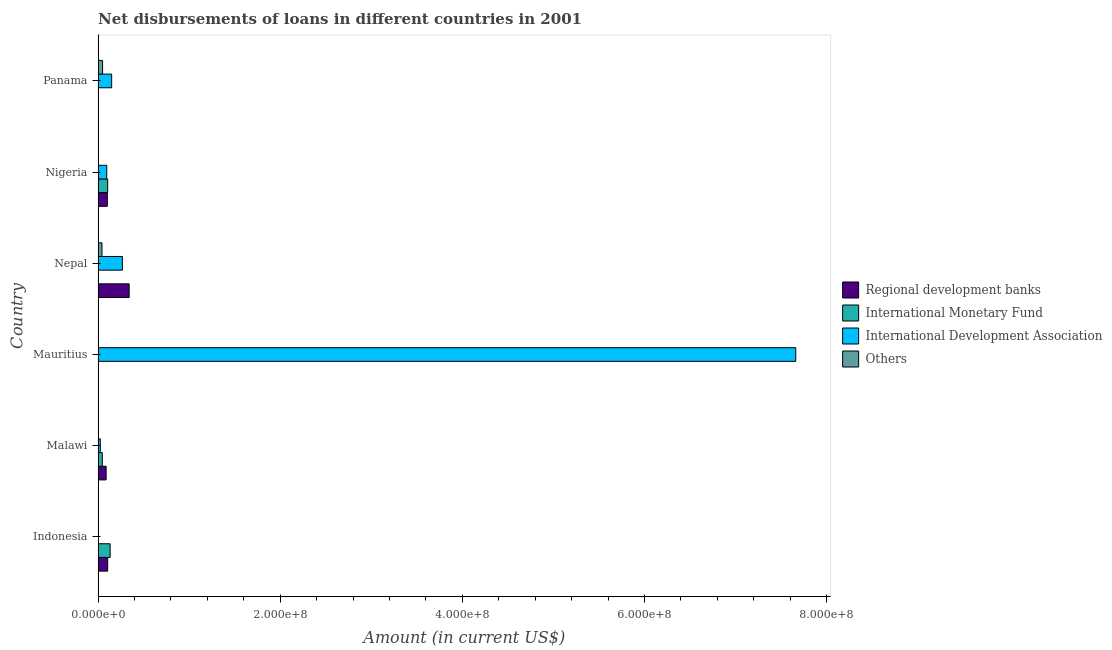Are the number of bars per tick equal to the number of legend labels?
Your answer should be compact. No. How many bars are there on the 3rd tick from the top?
Your response must be concise. 3. How many bars are there on the 4th tick from the bottom?
Offer a very short reply. 3. What is the label of the 3rd group of bars from the top?
Your answer should be compact. Nepal. What is the amount of loan disimbursed by other organisations in Indonesia?
Provide a short and direct response. 0. Across all countries, what is the maximum amount of loan disimbursed by international development association?
Give a very brief answer. 7.66e+08. Across all countries, what is the minimum amount of loan disimbursed by other organisations?
Make the answer very short. 0. In which country was the amount of loan disimbursed by international development association maximum?
Offer a very short reply. Mauritius. What is the total amount of loan disimbursed by international development association in the graph?
Your response must be concise. 8.19e+08. What is the difference between the amount of loan disimbursed by international monetary fund in Nigeria and the amount of loan disimbursed by international development association in Malawi?
Offer a terse response. 8.12e+06. What is the average amount of loan disimbursed by international development association per country?
Provide a succinct answer. 1.37e+08. What is the difference between the amount of loan disimbursed by international development association and amount of loan disimbursed by other organisations in Panama?
Offer a very short reply. 9.98e+06. What is the ratio of the amount of loan disimbursed by international development association in Mauritius to that in Nigeria?
Your response must be concise. 80.65. Is the amount of loan disimbursed by regional development banks in Indonesia less than that in Malawi?
Offer a terse response. No. What is the difference between the highest and the second highest amount of loan disimbursed by international monetary fund?
Provide a short and direct response. 2.71e+06. What is the difference between the highest and the lowest amount of loan disimbursed by regional development banks?
Offer a very short reply. 3.41e+07. In how many countries, is the amount of loan disimbursed by regional development banks greater than the average amount of loan disimbursed by regional development banks taken over all countries?
Provide a succinct answer. 1. Is the sum of the amount of loan disimbursed by international monetary fund in Indonesia and Malawi greater than the maximum amount of loan disimbursed by regional development banks across all countries?
Your answer should be very brief. No. Is it the case that in every country, the sum of the amount of loan disimbursed by regional development banks and amount of loan disimbursed by international monetary fund is greater than the amount of loan disimbursed by international development association?
Make the answer very short. No. How many bars are there?
Keep it short and to the point. 14. How many countries are there in the graph?
Ensure brevity in your answer.  6. Where does the legend appear in the graph?
Provide a short and direct response. Center right. How many legend labels are there?
Give a very brief answer. 4. What is the title of the graph?
Offer a very short reply. Net disbursements of loans in different countries in 2001. Does "Coal" appear as one of the legend labels in the graph?
Offer a very short reply. No. What is the label or title of the Y-axis?
Give a very brief answer. Country. What is the Amount (in current US$) of Regional development banks in Indonesia?
Keep it short and to the point. 1.05e+07. What is the Amount (in current US$) of International Monetary Fund in Indonesia?
Your answer should be compact. 1.32e+07. What is the Amount (in current US$) of Regional development banks in Malawi?
Make the answer very short. 8.80e+06. What is the Amount (in current US$) in International Monetary Fund in Malawi?
Ensure brevity in your answer.  4.59e+06. What is the Amount (in current US$) in International Development Association in Malawi?
Provide a succinct answer. 2.37e+06. What is the Amount (in current US$) in Others in Malawi?
Your answer should be very brief. 0. What is the Amount (in current US$) of Regional development banks in Mauritius?
Make the answer very short. 0. What is the Amount (in current US$) of International Monetary Fund in Mauritius?
Keep it short and to the point. 0. What is the Amount (in current US$) in International Development Association in Mauritius?
Your response must be concise. 7.66e+08. What is the Amount (in current US$) in Others in Mauritius?
Provide a short and direct response. 0. What is the Amount (in current US$) in Regional development banks in Nepal?
Your answer should be very brief. 3.41e+07. What is the Amount (in current US$) in International Development Association in Nepal?
Your response must be concise. 2.67e+07. What is the Amount (in current US$) of Others in Nepal?
Your response must be concise. 4.25e+06. What is the Amount (in current US$) in Regional development banks in Nigeria?
Ensure brevity in your answer.  1.01e+07. What is the Amount (in current US$) of International Monetary Fund in Nigeria?
Give a very brief answer. 1.05e+07. What is the Amount (in current US$) of International Development Association in Nigeria?
Keep it short and to the point. 9.50e+06. What is the Amount (in current US$) in Others in Nigeria?
Make the answer very short. 0. What is the Amount (in current US$) of International Monetary Fund in Panama?
Offer a very short reply. 0. What is the Amount (in current US$) in International Development Association in Panama?
Offer a very short reply. 1.49e+07. What is the Amount (in current US$) in Others in Panama?
Offer a very short reply. 4.90e+06. Across all countries, what is the maximum Amount (in current US$) of Regional development banks?
Provide a short and direct response. 3.41e+07. Across all countries, what is the maximum Amount (in current US$) of International Monetary Fund?
Offer a very short reply. 1.32e+07. Across all countries, what is the maximum Amount (in current US$) of International Development Association?
Provide a succinct answer. 7.66e+08. Across all countries, what is the maximum Amount (in current US$) in Others?
Your answer should be very brief. 4.90e+06. Across all countries, what is the minimum Amount (in current US$) of International Development Association?
Give a very brief answer. 0. Across all countries, what is the minimum Amount (in current US$) in Others?
Your answer should be compact. 0. What is the total Amount (in current US$) in Regional development banks in the graph?
Offer a very short reply. 6.35e+07. What is the total Amount (in current US$) in International Monetary Fund in the graph?
Your answer should be compact. 2.83e+07. What is the total Amount (in current US$) in International Development Association in the graph?
Your answer should be very brief. 8.19e+08. What is the total Amount (in current US$) in Others in the graph?
Make the answer very short. 9.15e+06. What is the difference between the Amount (in current US$) in Regional development banks in Indonesia and that in Malawi?
Your answer should be very brief. 1.70e+06. What is the difference between the Amount (in current US$) of International Monetary Fund in Indonesia and that in Malawi?
Give a very brief answer. 8.61e+06. What is the difference between the Amount (in current US$) of Regional development banks in Indonesia and that in Nepal?
Ensure brevity in your answer.  -2.36e+07. What is the difference between the Amount (in current US$) of Regional development banks in Indonesia and that in Nigeria?
Keep it short and to the point. 3.75e+05. What is the difference between the Amount (in current US$) of International Monetary Fund in Indonesia and that in Nigeria?
Offer a terse response. 2.71e+06. What is the difference between the Amount (in current US$) in International Development Association in Malawi and that in Mauritius?
Keep it short and to the point. -7.64e+08. What is the difference between the Amount (in current US$) of Regional development banks in Malawi and that in Nepal?
Provide a short and direct response. -2.53e+07. What is the difference between the Amount (in current US$) of International Development Association in Malawi and that in Nepal?
Ensure brevity in your answer.  -2.43e+07. What is the difference between the Amount (in current US$) of Regional development banks in Malawi and that in Nigeria?
Provide a succinct answer. -1.32e+06. What is the difference between the Amount (in current US$) in International Monetary Fund in Malawi and that in Nigeria?
Make the answer very short. -5.90e+06. What is the difference between the Amount (in current US$) in International Development Association in Malawi and that in Nigeria?
Provide a short and direct response. -7.13e+06. What is the difference between the Amount (in current US$) of International Development Association in Malawi and that in Panama?
Keep it short and to the point. -1.25e+07. What is the difference between the Amount (in current US$) in International Development Association in Mauritius and that in Nepal?
Offer a terse response. 7.39e+08. What is the difference between the Amount (in current US$) of International Development Association in Mauritius and that in Nigeria?
Your answer should be very brief. 7.57e+08. What is the difference between the Amount (in current US$) in International Development Association in Mauritius and that in Panama?
Provide a succinct answer. 7.51e+08. What is the difference between the Amount (in current US$) in Regional development banks in Nepal and that in Nigeria?
Offer a very short reply. 2.40e+07. What is the difference between the Amount (in current US$) of International Development Association in Nepal and that in Nigeria?
Your answer should be very brief. 1.72e+07. What is the difference between the Amount (in current US$) in International Development Association in Nepal and that in Panama?
Make the answer very short. 1.18e+07. What is the difference between the Amount (in current US$) in Others in Nepal and that in Panama?
Your answer should be compact. -6.45e+05. What is the difference between the Amount (in current US$) of International Development Association in Nigeria and that in Panama?
Offer a very short reply. -5.37e+06. What is the difference between the Amount (in current US$) in Regional development banks in Indonesia and the Amount (in current US$) in International Monetary Fund in Malawi?
Keep it short and to the point. 5.91e+06. What is the difference between the Amount (in current US$) in Regional development banks in Indonesia and the Amount (in current US$) in International Development Association in Malawi?
Keep it short and to the point. 8.13e+06. What is the difference between the Amount (in current US$) of International Monetary Fund in Indonesia and the Amount (in current US$) of International Development Association in Malawi?
Provide a succinct answer. 1.08e+07. What is the difference between the Amount (in current US$) of Regional development banks in Indonesia and the Amount (in current US$) of International Development Association in Mauritius?
Your response must be concise. -7.56e+08. What is the difference between the Amount (in current US$) in International Monetary Fund in Indonesia and the Amount (in current US$) in International Development Association in Mauritius?
Provide a succinct answer. -7.53e+08. What is the difference between the Amount (in current US$) in Regional development banks in Indonesia and the Amount (in current US$) in International Development Association in Nepal?
Offer a terse response. -1.62e+07. What is the difference between the Amount (in current US$) of Regional development banks in Indonesia and the Amount (in current US$) of Others in Nepal?
Offer a very short reply. 6.24e+06. What is the difference between the Amount (in current US$) in International Monetary Fund in Indonesia and the Amount (in current US$) in International Development Association in Nepal?
Give a very brief answer. -1.35e+07. What is the difference between the Amount (in current US$) in International Monetary Fund in Indonesia and the Amount (in current US$) in Others in Nepal?
Offer a terse response. 8.95e+06. What is the difference between the Amount (in current US$) in Regional development banks in Indonesia and the Amount (in current US$) in International Monetary Fund in Nigeria?
Your response must be concise. 9000. What is the difference between the Amount (in current US$) in Regional development banks in Indonesia and the Amount (in current US$) in International Development Association in Nigeria?
Offer a very short reply. 9.96e+05. What is the difference between the Amount (in current US$) in International Monetary Fund in Indonesia and the Amount (in current US$) in International Development Association in Nigeria?
Offer a terse response. 3.70e+06. What is the difference between the Amount (in current US$) in Regional development banks in Indonesia and the Amount (in current US$) in International Development Association in Panama?
Keep it short and to the point. -4.38e+06. What is the difference between the Amount (in current US$) of Regional development banks in Indonesia and the Amount (in current US$) of Others in Panama?
Make the answer very short. 5.60e+06. What is the difference between the Amount (in current US$) of International Monetary Fund in Indonesia and the Amount (in current US$) of International Development Association in Panama?
Provide a succinct answer. -1.67e+06. What is the difference between the Amount (in current US$) of International Monetary Fund in Indonesia and the Amount (in current US$) of Others in Panama?
Your answer should be very brief. 8.30e+06. What is the difference between the Amount (in current US$) in Regional development banks in Malawi and the Amount (in current US$) in International Development Association in Mauritius?
Provide a succinct answer. -7.57e+08. What is the difference between the Amount (in current US$) of International Monetary Fund in Malawi and the Amount (in current US$) of International Development Association in Mauritius?
Provide a short and direct response. -7.61e+08. What is the difference between the Amount (in current US$) in Regional development banks in Malawi and the Amount (in current US$) in International Development Association in Nepal?
Provide a short and direct response. -1.79e+07. What is the difference between the Amount (in current US$) in Regional development banks in Malawi and the Amount (in current US$) in Others in Nepal?
Keep it short and to the point. 4.54e+06. What is the difference between the Amount (in current US$) of International Monetary Fund in Malawi and the Amount (in current US$) of International Development Association in Nepal?
Make the answer very short. -2.21e+07. What is the difference between the Amount (in current US$) in International Monetary Fund in Malawi and the Amount (in current US$) in Others in Nepal?
Offer a very short reply. 3.34e+05. What is the difference between the Amount (in current US$) in International Development Association in Malawi and the Amount (in current US$) in Others in Nepal?
Keep it short and to the point. -1.88e+06. What is the difference between the Amount (in current US$) in Regional development banks in Malawi and the Amount (in current US$) in International Monetary Fund in Nigeria?
Ensure brevity in your answer.  -1.69e+06. What is the difference between the Amount (in current US$) of Regional development banks in Malawi and the Amount (in current US$) of International Development Association in Nigeria?
Provide a short and direct response. -7.01e+05. What is the difference between the Amount (in current US$) in International Monetary Fund in Malawi and the Amount (in current US$) in International Development Association in Nigeria?
Make the answer very short. -4.91e+06. What is the difference between the Amount (in current US$) of Regional development banks in Malawi and the Amount (in current US$) of International Development Association in Panama?
Offer a terse response. -6.08e+06. What is the difference between the Amount (in current US$) in Regional development banks in Malawi and the Amount (in current US$) in Others in Panama?
Offer a terse response. 3.90e+06. What is the difference between the Amount (in current US$) of International Monetary Fund in Malawi and the Amount (in current US$) of International Development Association in Panama?
Your response must be concise. -1.03e+07. What is the difference between the Amount (in current US$) of International Monetary Fund in Malawi and the Amount (in current US$) of Others in Panama?
Your response must be concise. -3.11e+05. What is the difference between the Amount (in current US$) in International Development Association in Malawi and the Amount (in current US$) in Others in Panama?
Provide a succinct answer. -2.53e+06. What is the difference between the Amount (in current US$) in International Development Association in Mauritius and the Amount (in current US$) in Others in Nepal?
Provide a succinct answer. 7.62e+08. What is the difference between the Amount (in current US$) of International Development Association in Mauritius and the Amount (in current US$) of Others in Panama?
Give a very brief answer. 7.61e+08. What is the difference between the Amount (in current US$) of Regional development banks in Nepal and the Amount (in current US$) of International Monetary Fund in Nigeria?
Your answer should be very brief. 2.36e+07. What is the difference between the Amount (in current US$) in Regional development banks in Nepal and the Amount (in current US$) in International Development Association in Nigeria?
Give a very brief answer. 2.46e+07. What is the difference between the Amount (in current US$) in Regional development banks in Nepal and the Amount (in current US$) in International Development Association in Panama?
Offer a very short reply. 1.92e+07. What is the difference between the Amount (in current US$) in Regional development banks in Nepal and the Amount (in current US$) in Others in Panama?
Make the answer very short. 2.92e+07. What is the difference between the Amount (in current US$) of International Development Association in Nepal and the Amount (in current US$) of Others in Panama?
Your answer should be compact. 2.18e+07. What is the difference between the Amount (in current US$) in Regional development banks in Nigeria and the Amount (in current US$) in International Development Association in Panama?
Offer a very short reply. -4.75e+06. What is the difference between the Amount (in current US$) of Regional development banks in Nigeria and the Amount (in current US$) of Others in Panama?
Offer a very short reply. 5.22e+06. What is the difference between the Amount (in current US$) of International Monetary Fund in Nigeria and the Amount (in current US$) of International Development Association in Panama?
Provide a short and direct response. -4.39e+06. What is the difference between the Amount (in current US$) in International Monetary Fund in Nigeria and the Amount (in current US$) in Others in Panama?
Provide a short and direct response. 5.59e+06. What is the difference between the Amount (in current US$) of International Development Association in Nigeria and the Amount (in current US$) of Others in Panama?
Keep it short and to the point. 4.60e+06. What is the average Amount (in current US$) in Regional development banks per country?
Your response must be concise. 1.06e+07. What is the average Amount (in current US$) in International Monetary Fund per country?
Make the answer very short. 4.71e+06. What is the average Amount (in current US$) of International Development Association per country?
Offer a very short reply. 1.37e+08. What is the average Amount (in current US$) in Others per country?
Keep it short and to the point. 1.52e+06. What is the difference between the Amount (in current US$) in Regional development banks and Amount (in current US$) in International Monetary Fund in Indonesia?
Your answer should be very brief. -2.70e+06. What is the difference between the Amount (in current US$) in Regional development banks and Amount (in current US$) in International Monetary Fund in Malawi?
Provide a succinct answer. 4.21e+06. What is the difference between the Amount (in current US$) of Regional development banks and Amount (in current US$) of International Development Association in Malawi?
Your response must be concise. 6.43e+06. What is the difference between the Amount (in current US$) in International Monetary Fund and Amount (in current US$) in International Development Association in Malawi?
Give a very brief answer. 2.22e+06. What is the difference between the Amount (in current US$) in Regional development banks and Amount (in current US$) in International Development Association in Nepal?
Your answer should be compact. 7.44e+06. What is the difference between the Amount (in current US$) of Regional development banks and Amount (in current US$) of Others in Nepal?
Your response must be concise. 2.98e+07. What is the difference between the Amount (in current US$) in International Development Association and Amount (in current US$) in Others in Nepal?
Make the answer very short. 2.24e+07. What is the difference between the Amount (in current US$) of Regional development banks and Amount (in current US$) of International Monetary Fund in Nigeria?
Offer a very short reply. -3.66e+05. What is the difference between the Amount (in current US$) of Regional development banks and Amount (in current US$) of International Development Association in Nigeria?
Provide a succinct answer. 6.21e+05. What is the difference between the Amount (in current US$) in International Monetary Fund and Amount (in current US$) in International Development Association in Nigeria?
Make the answer very short. 9.87e+05. What is the difference between the Amount (in current US$) of International Development Association and Amount (in current US$) of Others in Panama?
Your answer should be compact. 9.98e+06. What is the ratio of the Amount (in current US$) in Regional development banks in Indonesia to that in Malawi?
Your answer should be very brief. 1.19. What is the ratio of the Amount (in current US$) in International Monetary Fund in Indonesia to that in Malawi?
Ensure brevity in your answer.  2.88. What is the ratio of the Amount (in current US$) in Regional development banks in Indonesia to that in Nepal?
Your answer should be very brief. 0.31. What is the ratio of the Amount (in current US$) of Regional development banks in Indonesia to that in Nigeria?
Make the answer very short. 1.04. What is the ratio of the Amount (in current US$) of International Monetary Fund in Indonesia to that in Nigeria?
Offer a very short reply. 1.26. What is the ratio of the Amount (in current US$) of International Development Association in Malawi to that in Mauritius?
Ensure brevity in your answer.  0. What is the ratio of the Amount (in current US$) of Regional development banks in Malawi to that in Nepal?
Offer a very short reply. 0.26. What is the ratio of the Amount (in current US$) in International Development Association in Malawi to that in Nepal?
Your answer should be very brief. 0.09. What is the ratio of the Amount (in current US$) in Regional development banks in Malawi to that in Nigeria?
Provide a succinct answer. 0.87. What is the ratio of the Amount (in current US$) of International Monetary Fund in Malawi to that in Nigeria?
Make the answer very short. 0.44. What is the ratio of the Amount (in current US$) in International Development Association in Malawi to that in Nigeria?
Ensure brevity in your answer.  0.25. What is the ratio of the Amount (in current US$) of International Development Association in Malawi to that in Panama?
Provide a short and direct response. 0.16. What is the ratio of the Amount (in current US$) of International Development Association in Mauritius to that in Nepal?
Keep it short and to the point. 28.73. What is the ratio of the Amount (in current US$) of International Development Association in Mauritius to that in Nigeria?
Offer a very short reply. 80.65. What is the ratio of the Amount (in current US$) of International Development Association in Mauritius to that in Panama?
Offer a terse response. 51.51. What is the ratio of the Amount (in current US$) of Regional development banks in Nepal to that in Nigeria?
Provide a succinct answer. 3.37. What is the ratio of the Amount (in current US$) of International Development Association in Nepal to that in Nigeria?
Your response must be concise. 2.81. What is the ratio of the Amount (in current US$) in International Development Association in Nepal to that in Panama?
Provide a succinct answer. 1.79. What is the ratio of the Amount (in current US$) in Others in Nepal to that in Panama?
Make the answer very short. 0.87. What is the ratio of the Amount (in current US$) in International Development Association in Nigeria to that in Panama?
Provide a succinct answer. 0.64. What is the difference between the highest and the second highest Amount (in current US$) in Regional development banks?
Offer a terse response. 2.36e+07. What is the difference between the highest and the second highest Amount (in current US$) in International Monetary Fund?
Offer a terse response. 2.71e+06. What is the difference between the highest and the second highest Amount (in current US$) in International Development Association?
Keep it short and to the point. 7.39e+08. What is the difference between the highest and the lowest Amount (in current US$) of Regional development banks?
Your answer should be very brief. 3.41e+07. What is the difference between the highest and the lowest Amount (in current US$) of International Monetary Fund?
Make the answer very short. 1.32e+07. What is the difference between the highest and the lowest Amount (in current US$) in International Development Association?
Provide a succinct answer. 7.66e+08. What is the difference between the highest and the lowest Amount (in current US$) of Others?
Your answer should be very brief. 4.90e+06. 